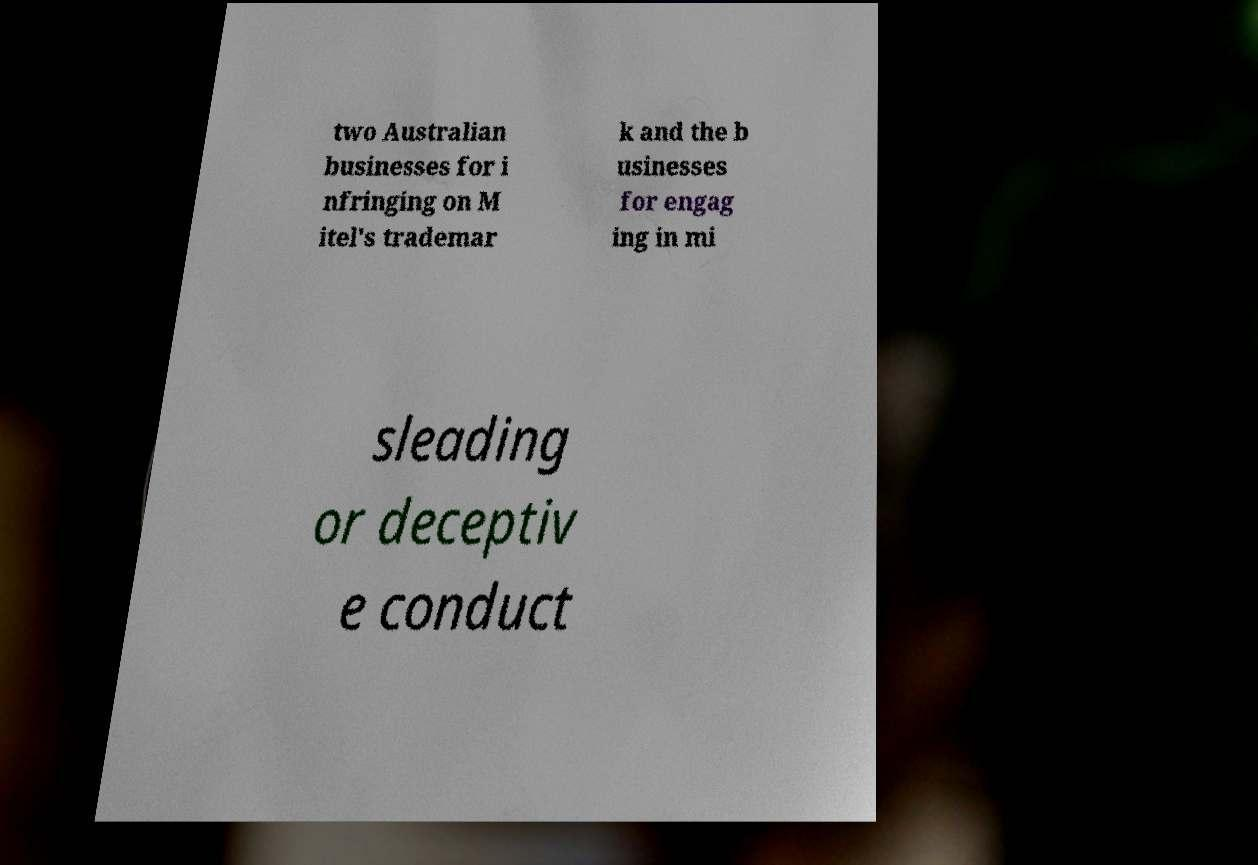There's text embedded in this image that I need extracted. Can you transcribe it verbatim? two Australian businesses for i nfringing on M itel's trademar k and the b usinesses for engag ing in mi sleading or deceptiv e conduct 